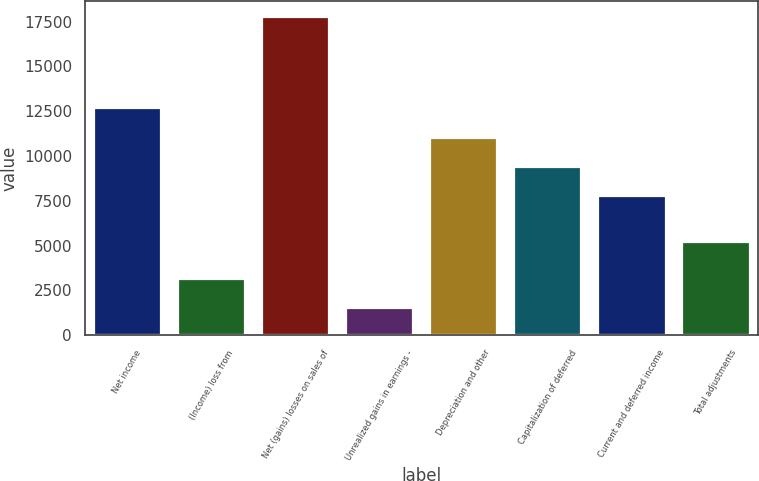Convert chart to OTSL. <chart><loc_0><loc_0><loc_500><loc_500><bar_chart><fcel>Net income<fcel>(Income) loss from<fcel>Net (gains) losses on sales of<fcel>Unrealized gains in earnings -<fcel>Depreciation and other<fcel>Capitalization of deferred<fcel>Current and deferred income<fcel>Total adjustments<nl><fcel>12657.4<fcel>3134.8<fcel>17767<fcel>1509<fcel>11031.6<fcel>9405.8<fcel>7780<fcel>5201<nl></chart> 